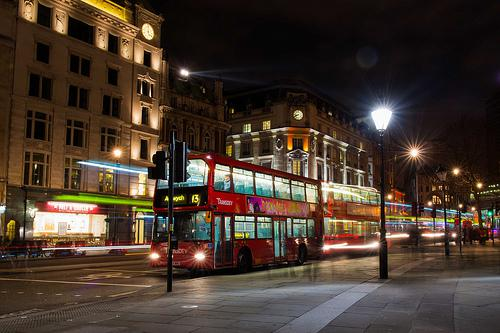Question: when was this picture taken?
Choices:
A. During an eclipse.
B. During a volcanic eruption.
C. Night time.
D. Sunrise.
Answer with the letter. Answer: C Question: what is in the picture?
Choices:
A. Buses.
B. A cat.
C. His shirt.
D. The car.
Answer with the letter. Answer: A Question: how is the weather?
Choices:
A. Lovely.
B. Sweltering.
C. Clear.
D. Frigid.
Answer with the letter. Answer: C Question: what size are the buses?
Choices:
A. Small.
B. Toy sized.
C. Huge.
D. Double deckers.
Answer with the letter. Answer: D 